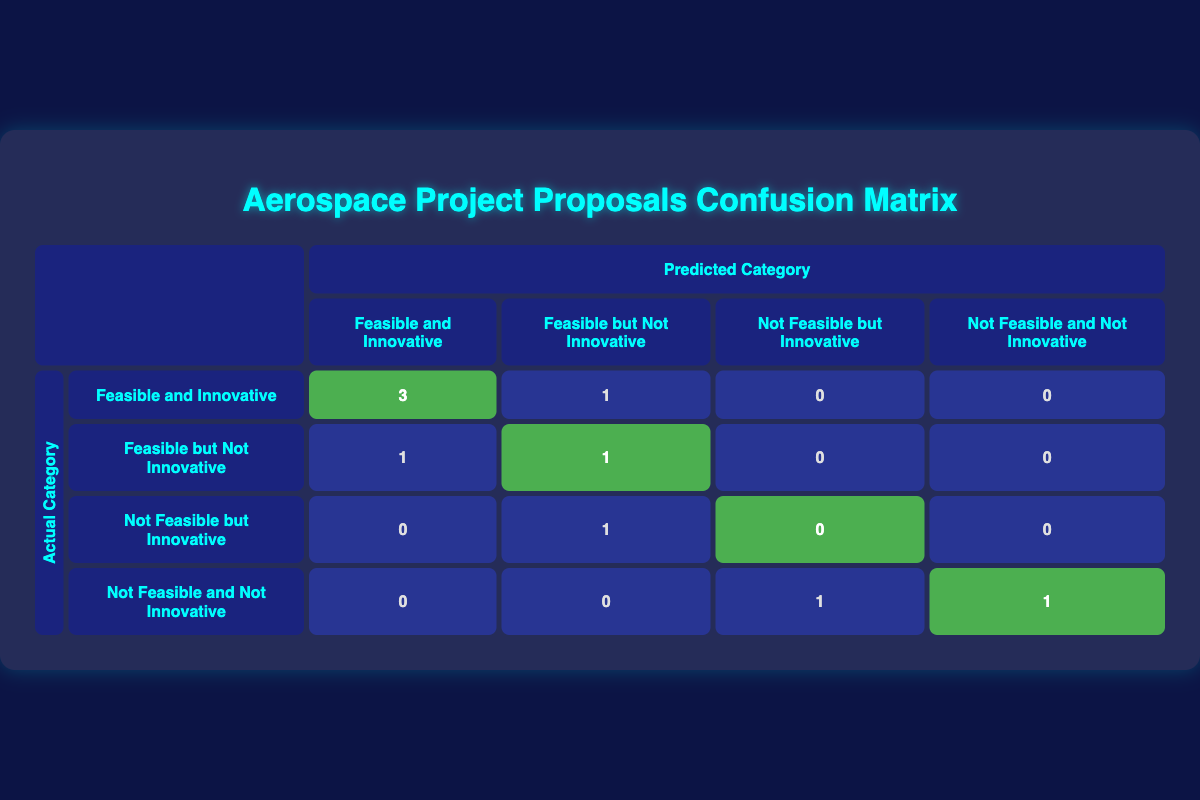What is the total number of projects classified as "Feasible and Innovative"? To get the total number, count the values in the "Feasible and Innovative" column under the actual category. There are 3 entries (including those predicted correctly) for "Feasible and Innovative" and 3 entries total for this group. The total is 3.
Answer: 3 How many projects were predicted to be "Not Feasible but Innovative"? The column "Not Feasible but Innovative" has 0 projects that were correctly predicted and 1 project that was misclassified among the 10 total projects. By checking this column, it remains 1 as the count.
Answer: 1 What percentage of projects were accurately categorized as "Feasible and Innovative"? To find the percentage, identify the number of correct predictions for "Feasible and Innovative." This is 3 out of a total of 10 projects. Thus, the percentage is (3/10) * 100 = 30%.
Answer: 30% How many projects were incorrectly predicted as "Feasible but Not Innovative"? In the "Feasible but Not Innovative" row for predicted projects, there is 1 project accurately predicted. However, there is 1 project wrongly classified into this group (the Mars Sample Return Rover), giving 1 overall.
Answer: 1 Are there any projects that were predicted as "Not Feasible and Not Innovative"? To determine this, check the "Not Feasible and Not Innovative" column under predicted categories. There is one project (the Interstellar Probe Concept) correctly predicted, but another project was also misclassified; thus, the answer is yes.
Answer: Yes What are the total false negatives for the "Feasible and Innovative" category? The false negatives are the projects that are actually "Feasible and Innovative" but were misclassified in other categories. Here, 1 project was actually "Feasible and Innovative" but predicted as "Feasible but Not Innovative." Thus, there is 1.
Answer: 1 What is the ratio of correctly predicted to incorrectly predicted "Feasible but Not Innovative" projects? There is 1 correctly predicted project and 1 incorrectly predicted project in this category. Therefore, the ratio is 1:1.
Answer: 1:1 How many projects are there in total that are considered "Not Feasible"? To find this, look for projects in the actual categories that fall under "Not Feasible." The combinations are 2 (from the "Not Feasible but Innovative" and "Not Feasible and Not Innovative" categories).
Answer: 2 